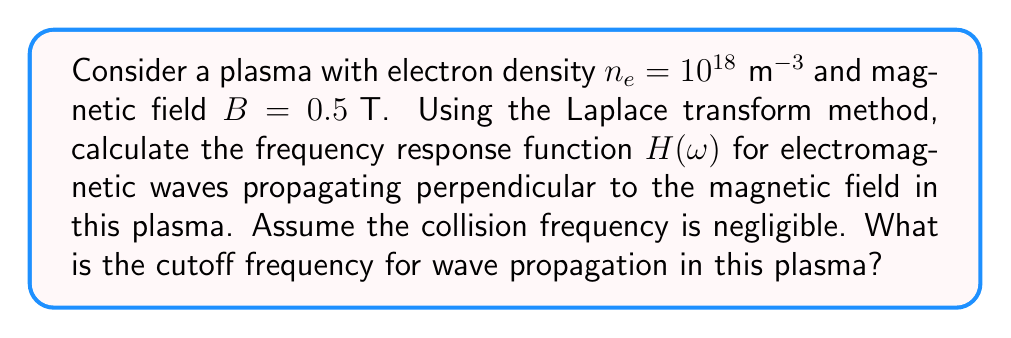Teach me how to tackle this problem. To solve this problem, we'll follow these steps:

1) First, recall the equation of motion for electrons in a plasma under the influence of an electromagnetic wave:

   $$m\frac{d^2\mathbf{r}}{dt^2} = -e\mathbf{E} - e\frac{d\mathbf{r}}{dt} \times \mathbf{B}$$

2) For waves propagating perpendicular to the magnetic field, we can simplify this to two coupled equations:

   $$\frac{d^2x}{dt^2} = -\frac{e}{m}E_x + \omega_c\frac{dy}{dt}$$
   $$\frac{d^2y}{dt^2} = -\frac{e}{m}E_y - \omega_c\frac{dx}{dt}$$

   where $\omega_c = \frac{eB}{m}$ is the cyclotron frequency.

3) Taking the Laplace transform of these equations:

   $$s^2X(s) = -\frac{e}{m}E_x(s) + \omega_c sY(s)$$
   $$s^2Y(s) = -\frac{e}{m}E_y(s) - \omega_c sX(s)$$

4) Solving this system of equations for $X(s)$ and $Y(s)$:

   $$X(s) = -\frac{e}{m}\frac{s E_x(s) + \omega_c E_y(s)}{s^2(s^2 + \omega_c^2)}$$
   $$Y(s) = -\frac{e}{m}\frac{s E_y(s) - \omega_c E_x(s)}{s^2(s^2 + \omega_c^2)}$$

5) The frequency response function $H(\omega)$ is obtained by substituting $s = i\omega$:

   $$H(\omega) = -\frac{e}{m}\frac{1}{\omega^2 - \omega_c^2}$$

6) The plasma frequency is given by:

   $$\omega_p = \sqrt{\frac{n_e e^2}{m\epsilon_0}}$$

7) Substituting the given values:

   $$\omega_p = \sqrt{\frac{(10^{18})(1.6 \times 10^{-19})^2}{(9.1 \times 10^{-31})(8.85 \times 10^{-12})} = 5.64 \times 10^{9} \text{ rad/s}$$

8) The cyclotron frequency is:

   $$\omega_c = \frac{eB}{m} = \frac{(1.6 \times 10^{-19})(0.5)}{9.1 \times 10^{-31}} = 8.79 \times 10^{10} \text{ rad/s}$$

9) The cutoff frequency for perpendicular propagation is given by:

   $$\omega_\text{cutoff} = \sqrt{\omega_p^2 + \omega_c^2}$$

10) Substituting the calculated values:

    $$\omega_\text{cutoff} = \sqrt{(5.64 \times 10^{9})^2 + (8.79 \times 10^{10})^2} = 8.81 \times 10^{10} \text{ rad/s}$$
Answer: The frequency response function is:

$$H(\omega) = -\frac{e}{m}\frac{1}{\omega^2 - \omega_c^2}$$

The cutoff frequency for wave propagation in this plasma is:

$$\omega_\text{cutoff} = 8.81 \times 10^{10} \text{ rad/s}$$ 